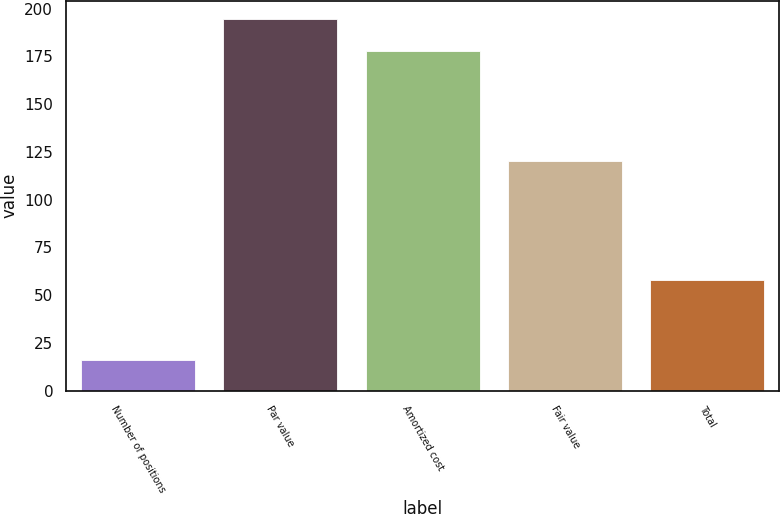Convert chart to OTSL. <chart><loc_0><loc_0><loc_500><loc_500><bar_chart><fcel>Number of positions<fcel>Par value<fcel>Amortized cost<fcel>Fair value<fcel>Total<nl><fcel>16<fcel>194.5<fcel>178<fcel>120<fcel>58<nl></chart> 